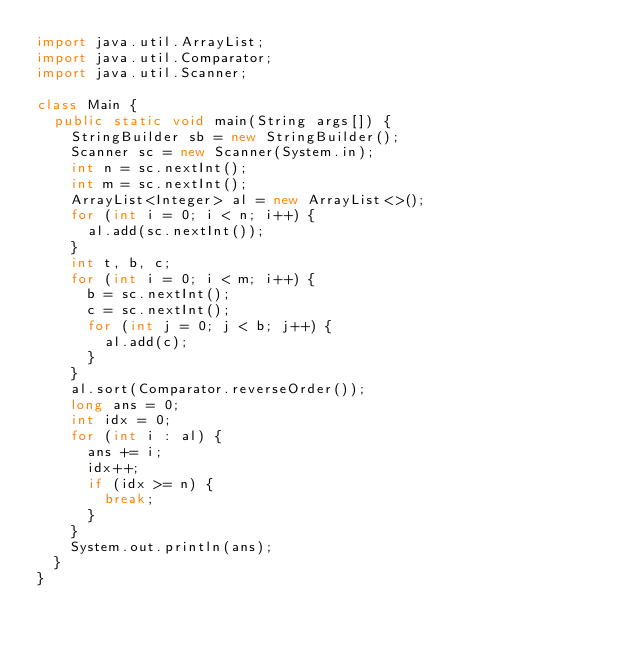Convert code to text. <code><loc_0><loc_0><loc_500><loc_500><_Java_>import java.util.ArrayList;
import java.util.Comparator;
import java.util.Scanner;

class Main {
	public static void main(String args[]) {
		StringBuilder sb = new StringBuilder();
		Scanner sc = new Scanner(System.in);
		int n = sc.nextInt();
		int m = sc.nextInt();
		ArrayList<Integer> al = new ArrayList<>();
		for (int i = 0; i < n; i++) {
			al.add(sc.nextInt());
		}
		int t, b, c;
		for (int i = 0; i < m; i++) {
			b = sc.nextInt();
			c = sc.nextInt();
			for (int j = 0; j < b; j++) {
				al.add(c);
			}
		}
		al.sort(Comparator.reverseOrder());
		long ans = 0;
		int idx = 0;
		for (int i : al) {
			ans += i;
			idx++;
			if (idx >= n) {
				break;
			}
		}
		System.out.println(ans);
	}
}</code> 